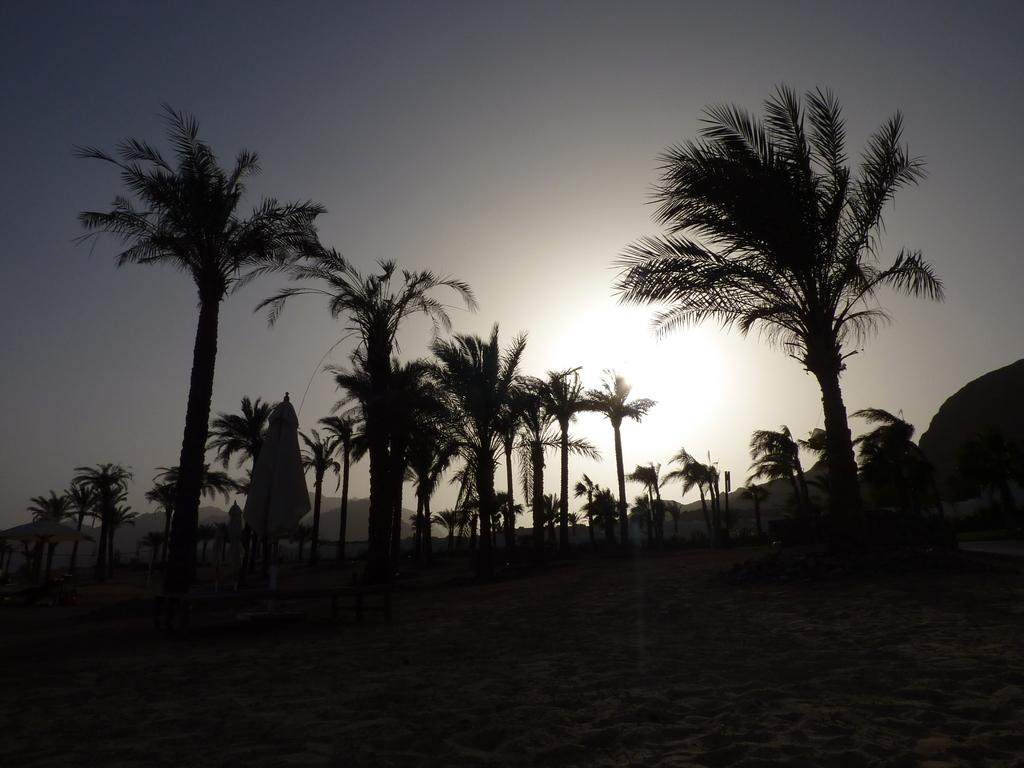What type of natural elements can be seen in the image? There are trees in the image. What celestial body is visible in the background of the image? The sun is visible in the background of the image. What else can be seen in the background of the image? The sky is visible in the background of the image. How would you describe the lighting in the image? The image appears to be slightly dark. How much salt is present on the trees in the image? There is no salt present on the trees in the image, as salt is not a natural element found on trees. 